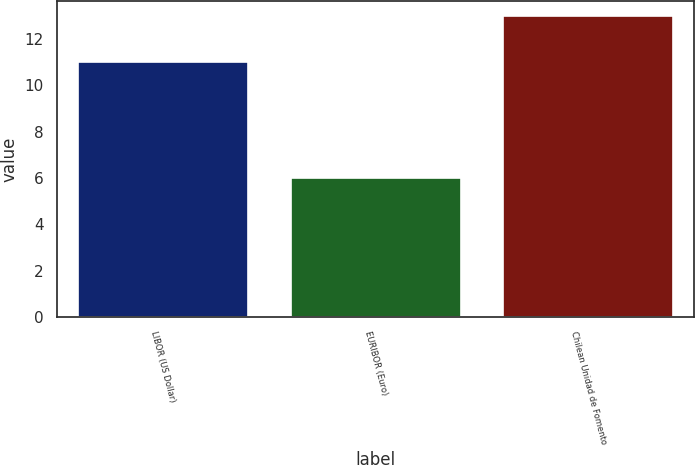Convert chart to OTSL. <chart><loc_0><loc_0><loc_500><loc_500><bar_chart><fcel>LIBOR (US Dollar)<fcel>EURIBOR (Euro)<fcel>Chilean Unidad de Fomento<nl><fcel>11<fcel>6<fcel>13<nl></chart> 